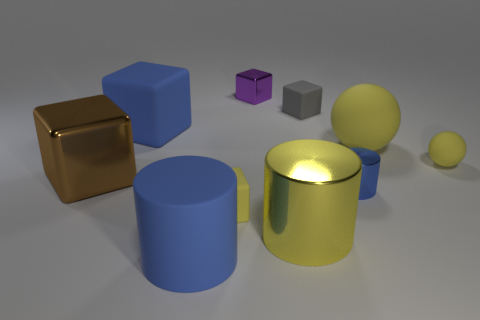There is a block that is the same color as the tiny cylinder; what is it made of?
Provide a succinct answer. Rubber. Are there fewer rubber cylinders that are right of the large metallic cylinder than tiny gray matte objects?
Offer a terse response. Yes. Is the material of the small yellow thing on the right side of the large yellow rubber thing the same as the yellow block?
Give a very brief answer. Yes. There is a small cylinder that is made of the same material as the small purple thing; what is its color?
Provide a short and direct response. Blue. Is the number of shiny things that are in front of the large matte block less than the number of yellow shiny objects that are in front of the big blue matte cylinder?
Ensure brevity in your answer.  No. Is the color of the small object on the left side of the purple object the same as the metal cylinder that is left of the small gray rubber block?
Your answer should be compact. Yes. Is there a large brown block made of the same material as the small gray block?
Your answer should be compact. No. There is a blue cylinder that is on the right side of the metallic cube right of the large blue block; what is its size?
Offer a terse response. Small. Are there more matte cubes than shiny objects?
Ensure brevity in your answer.  No. There is a blue thing on the right side of the yellow block; is it the same size as the big brown thing?
Your response must be concise. No. 